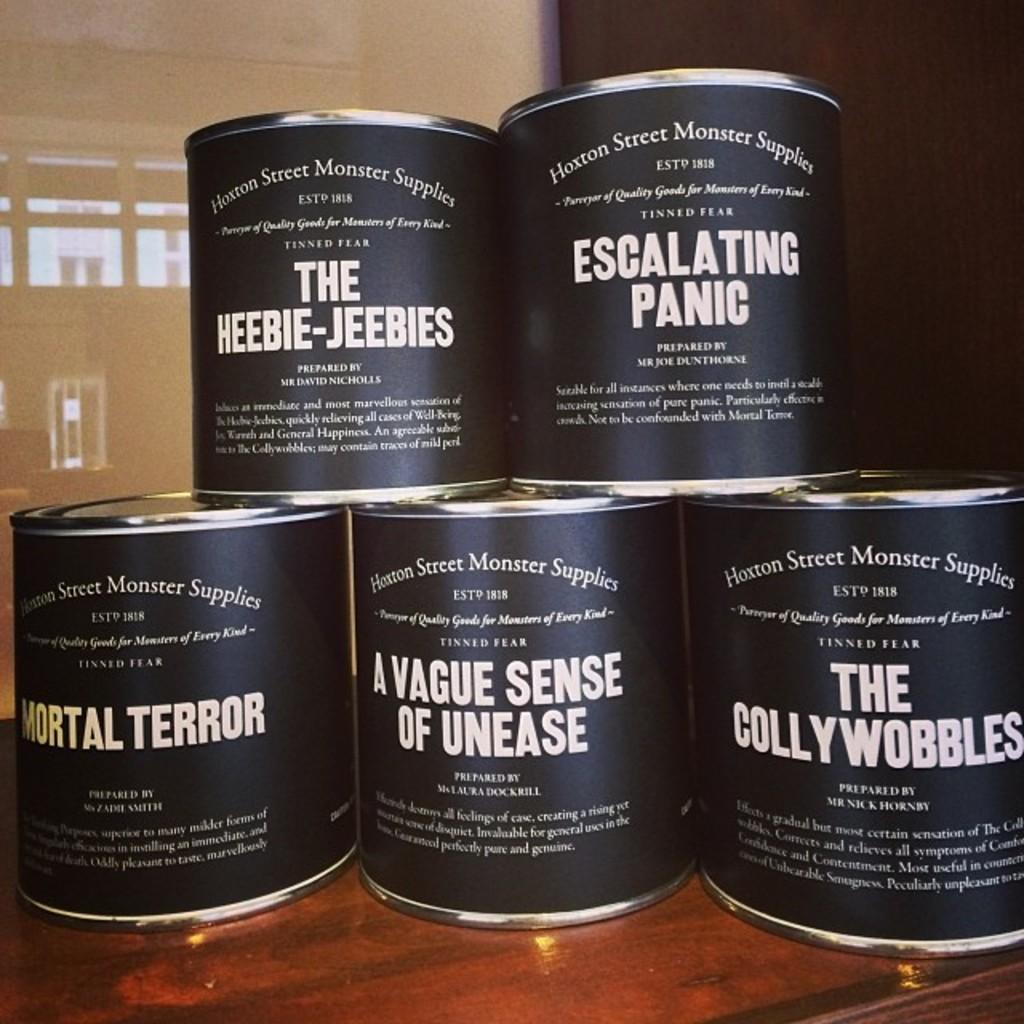<image>
Describe the image concisely. five can of goods by the hoxton street monster supplies 